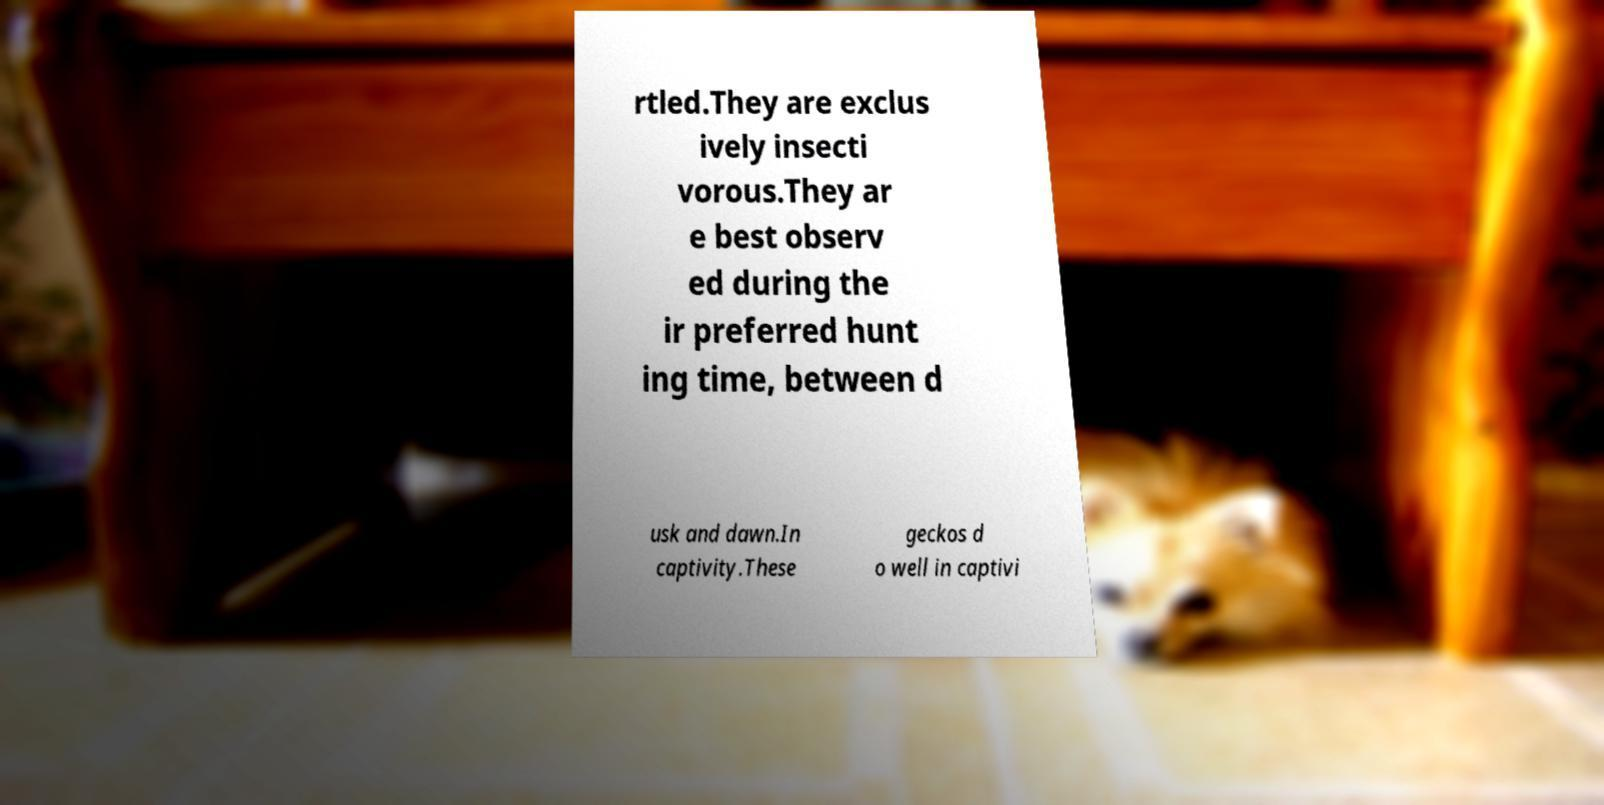Could you extract and type out the text from this image? rtled.They are exclus ively insecti vorous.They ar e best observ ed during the ir preferred hunt ing time, between d usk and dawn.In captivity.These geckos d o well in captivi 